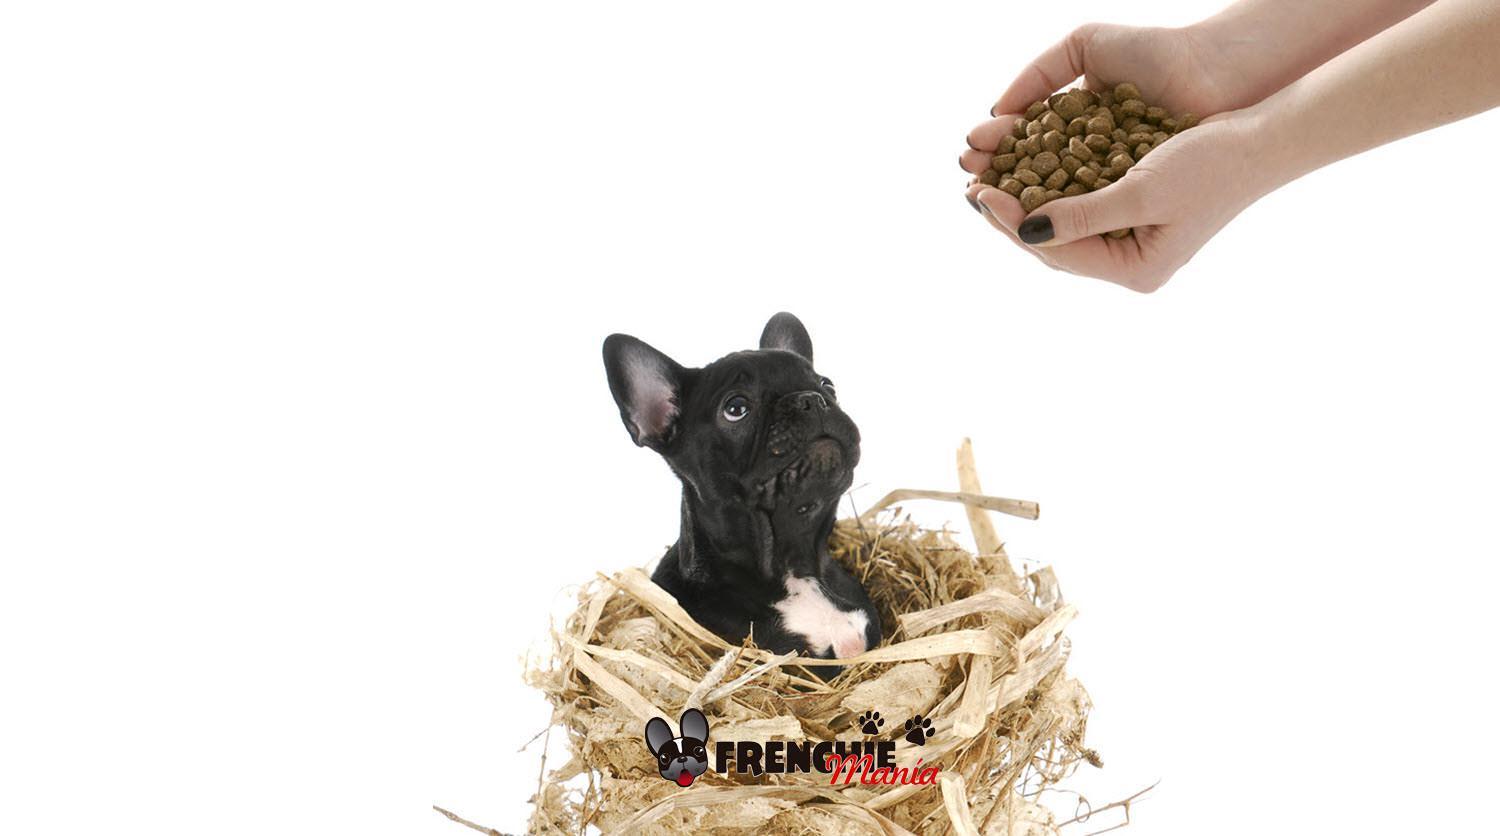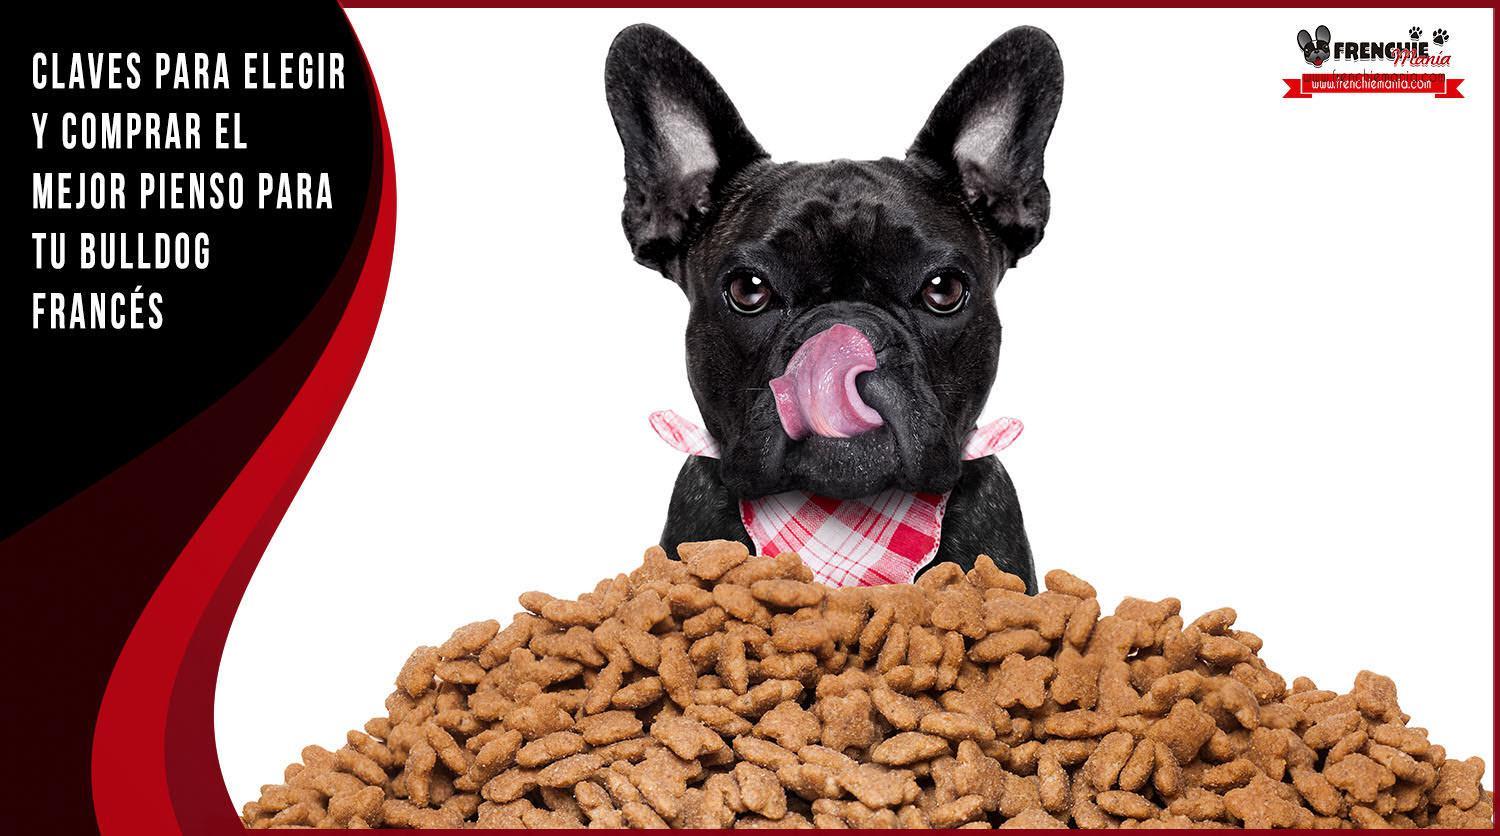The first image is the image on the left, the second image is the image on the right. For the images displayed, is the sentence "One dog is wearing a bib." factually correct? Answer yes or no. Yes. The first image is the image on the left, the second image is the image on the right. Considering the images on both sides, is "There is a dog sitting in a pile of dog treats." valid? Answer yes or no. Yes. 